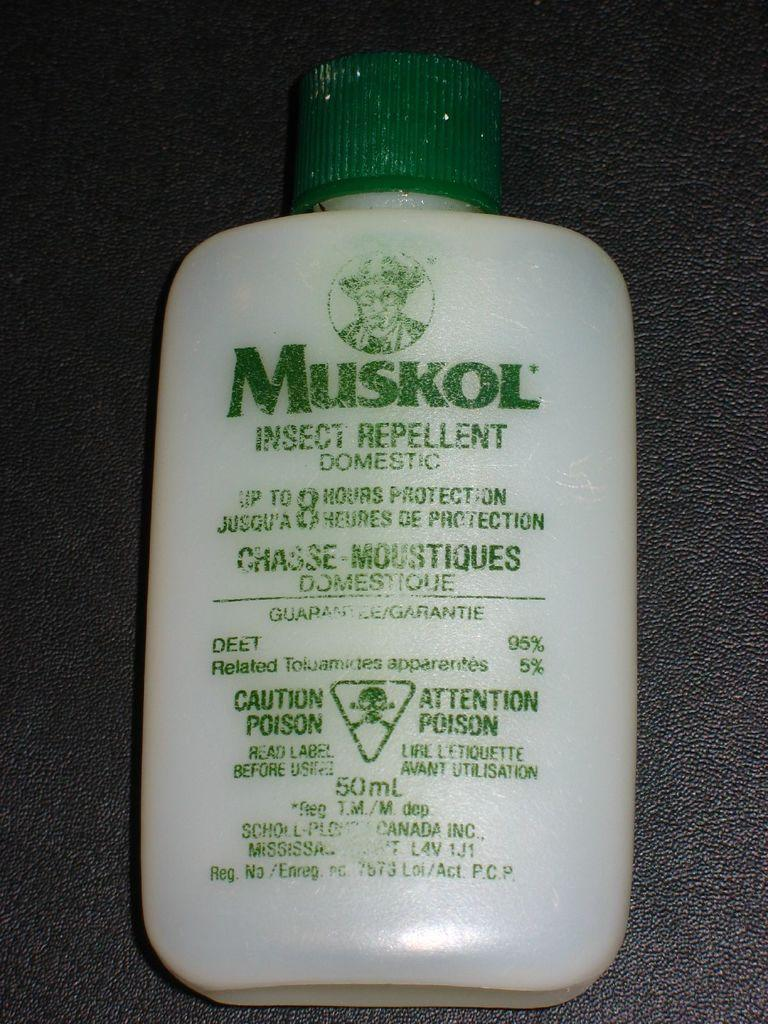Provide a one-sentence caption for the provided image. Insect repellent bottle from the maker Muskol that provides up to 8 hours of protection. 